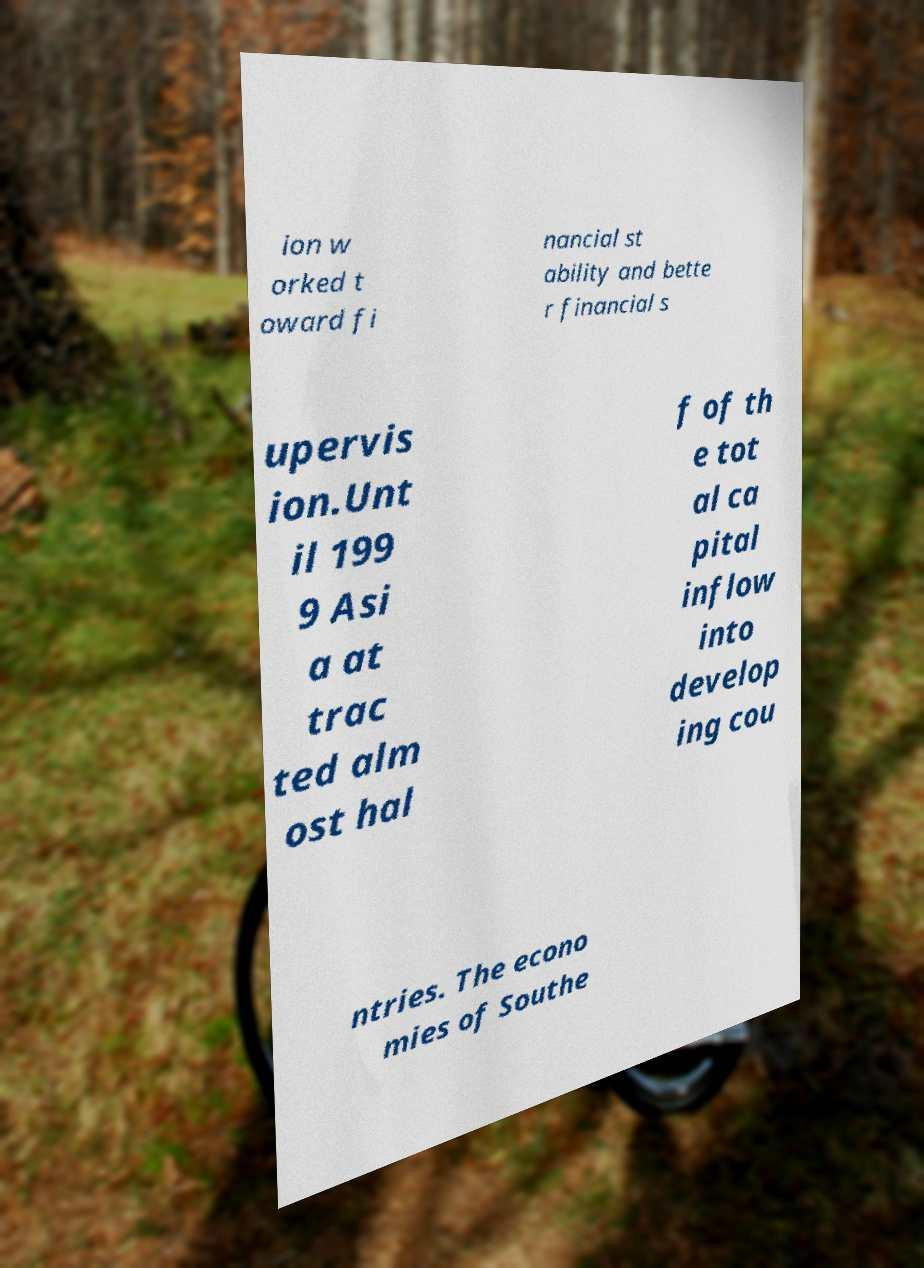Could you extract and type out the text from this image? ion w orked t oward fi nancial st ability and bette r financial s upervis ion.Unt il 199 9 Asi a at trac ted alm ost hal f of th e tot al ca pital inflow into develop ing cou ntries. The econo mies of Southe 